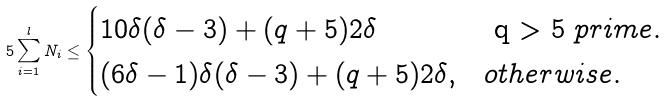Convert formula to latex. <formula><loc_0><loc_0><loc_500><loc_500>5 \sum _ { i = 1 } ^ { l } N _ { i } \leq \begin{cases} 1 0 \delta ( \delta - 3 ) + ( q + 5 ) 2 \delta & $ q > 5 $ p r i m e \/ . \\ ( 6 \delta - 1 ) \delta ( \delta - 3 ) + ( q + 5 ) 2 \delta , & o t h e r w i s e . \\ \end{cases}</formula> 